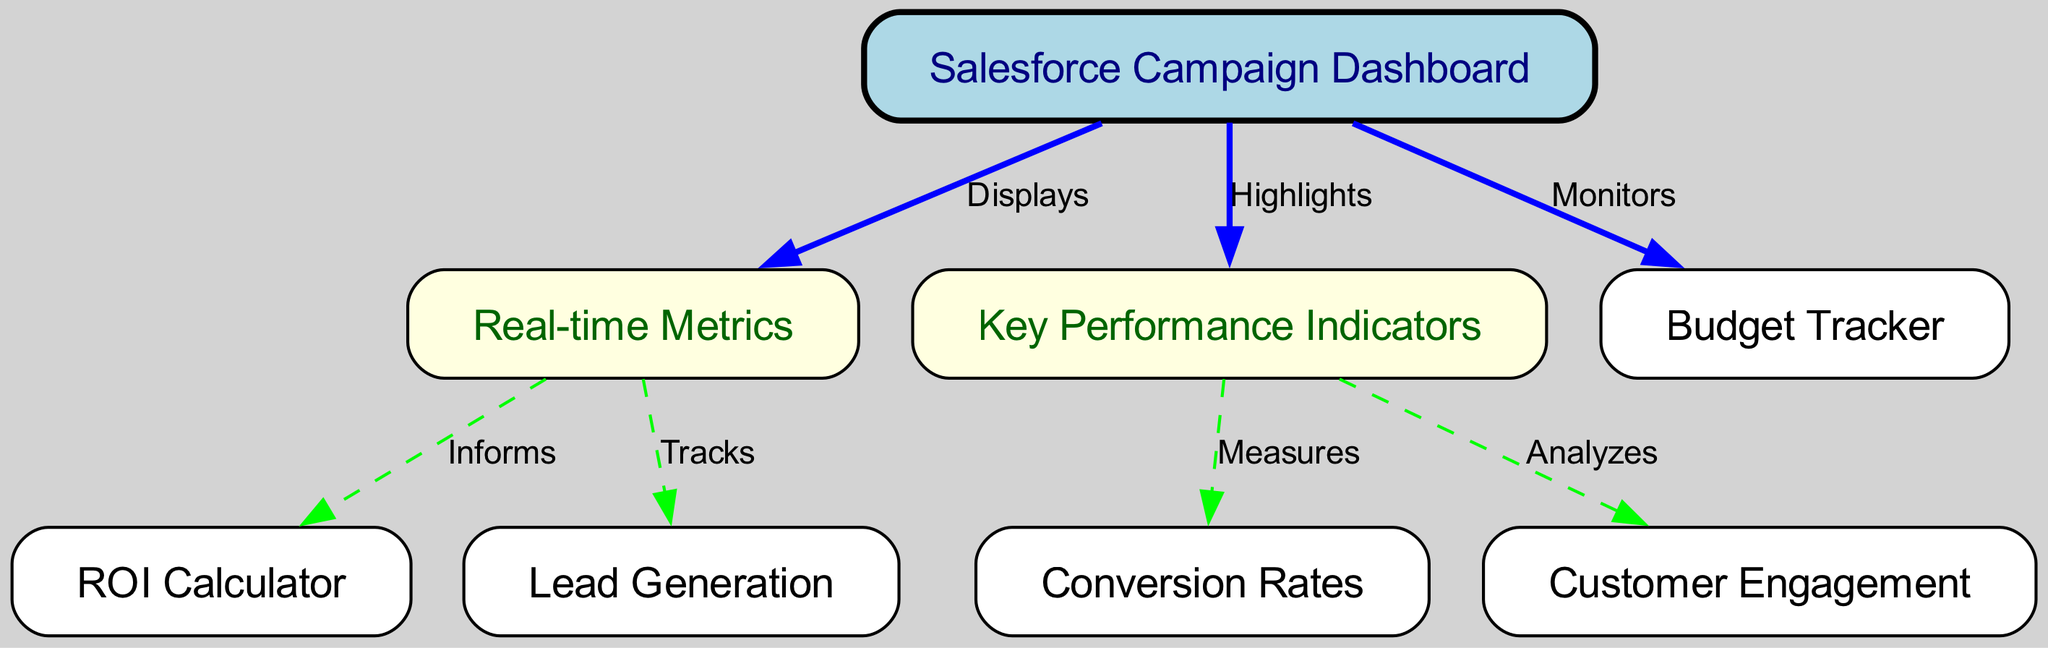What is the main focus of the diagram? The diagram is centered around the "Salesforce Campaign Dashboard," which serves as the primary node from which all metrics and KPIs branch out.
Answer: Salesforce Campaign Dashboard How many nodes are there in total? There is a total of eight nodes displayed in the diagram: Dashboard, Real-time Metrics, Key Performance Indicators, ROI Calculator, Lead Generation, Conversion Rates, Customer Engagement, and Budget Tracker.
Answer: Eight What does the dashboard display? The dashboard displays "Real-time Metrics" and highlights "Key Performance Indicators," which are indicated by the directed edges leading from the dashboard to both metrics and KPIs.
Answer: Real-time Metrics, Key Performance Indicators Which node tracks lead generation? The node "Lead Generation" is tracked by the "Real-time Metrics" node, as shown by the edge labeled "Tracks" connecting them.
Answer: Lead Generation What informs the ROI Calculator? The "Real-time Metrics" node informs the ROI Calculator, as indicated by the edge labeled "Informs" connecting these two nodes.
Answer: Real-time Metrics What relationship exists between KPIs and conversion rates? The node "Key Performance Indicators" measures the "Conversion Rates," as reflected by the edge labeled "Measures" in the diagram.
Answer: Measures How many edges originate from the dashboard? Three edges originate from the dashboard node, which connect to "Real-time Metrics," "Key Performance Indicators," and "Budget Tracker."
Answer: Three What does the KPI node analyze? The KPI node analyzes "Customer Engagement," which is connected to it by the edge labeled "Analyzes."
Answer: Customer Engagement Which metric monitors the budget? The edge labeled "Monitors" indicates that the budget is monitored directly by the "Salesforce Campaign Dashboard."
Answer: Budget Tracker 